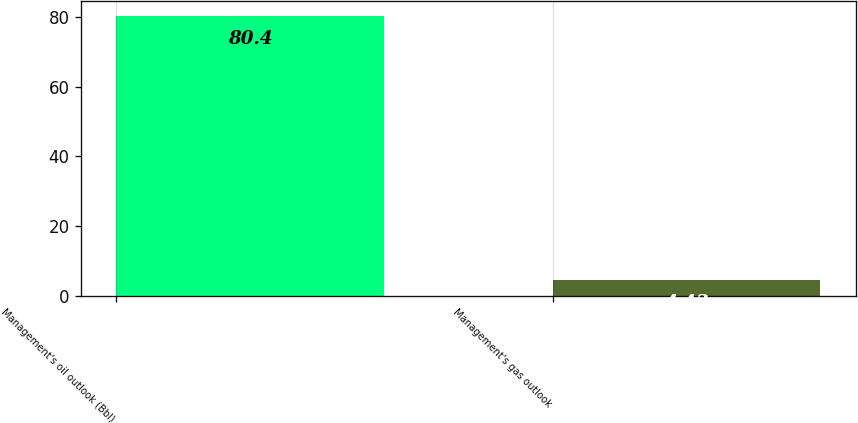Convert chart. <chart><loc_0><loc_0><loc_500><loc_500><bar_chart><fcel>Management's oil outlook (Bbl)<fcel>Management's gas outlook<nl><fcel>80.4<fcel>4.43<nl></chart> 